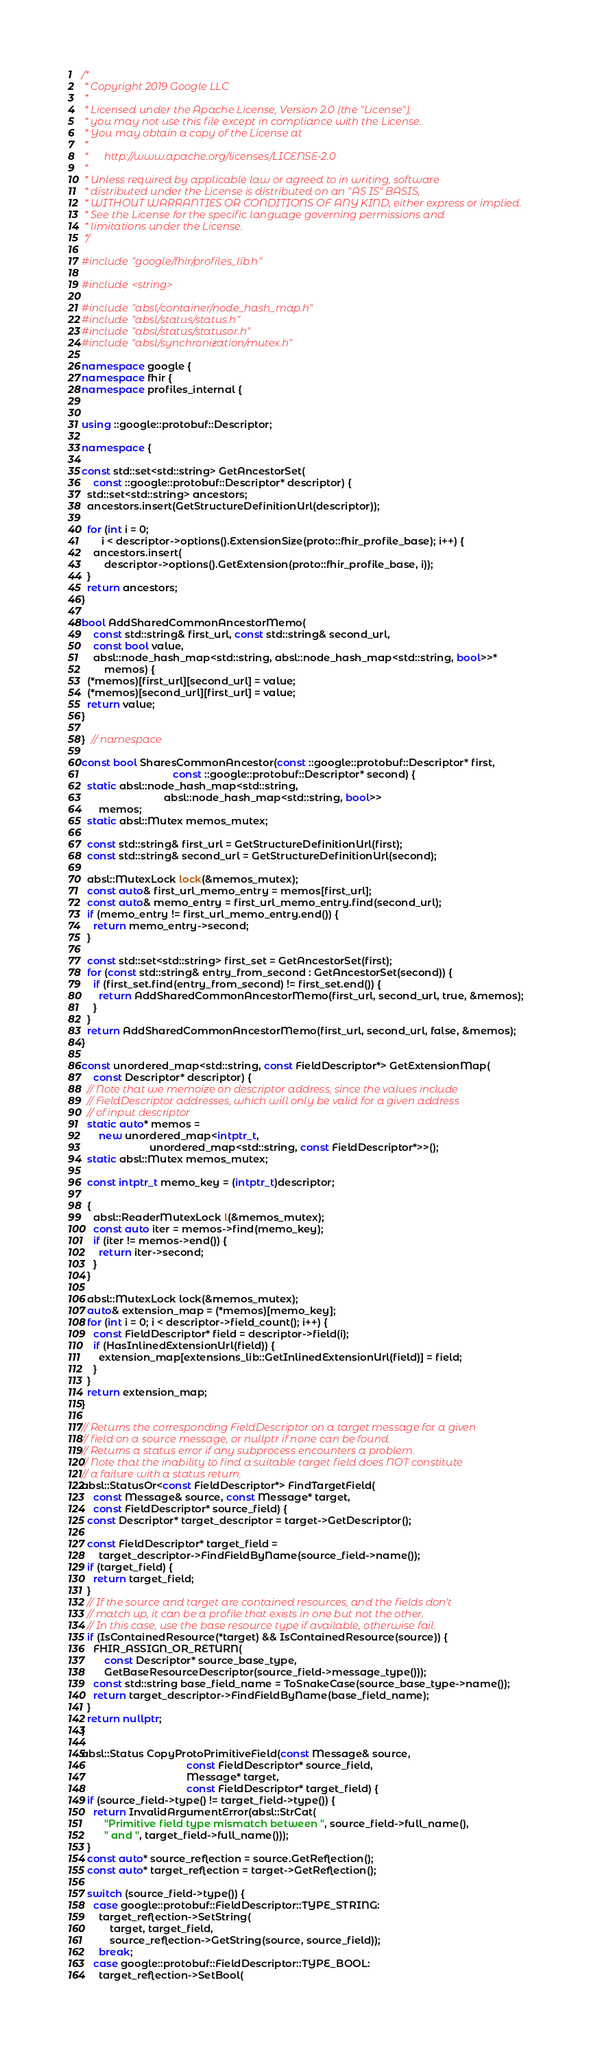Convert code to text. <code><loc_0><loc_0><loc_500><loc_500><_C++_>/*
 * Copyright 2019 Google LLC
 *
 * Licensed under the Apache License, Version 2.0 (the "License");
 * you may not use this file except in compliance with the License.
 * You may obtain a copy of the License at
 *
 *      http://www.apache.org/licenses/LICENSE-2.0
 *
 * Unless required by applicable law or agreed to in writing, software
 * distributed under the License is distributed on an "AS IS" BASIS,
 * WITHOUT WARRANTIES OR CONDITIONS OF ANY KIND, either express or implied.
 * See the License for the specific language governing permissions and
 * limitations under the License.
 */

#include "google/fhir/profiles_lib.h"

#include <string>

#include "absl/container/node_hash_map.h"
#include "absl/status/status.h"
#include "absl/status/statusor.h"
#include "absl/synchronization/mutex.h"

namespace google {
namespace fhir {
namespace profiles_internal {


using ::google::protobuf::Descriptor;

namespace {

const std::set<std::string> GetAncestorSet(
    const ::google::protobuf::Descriptor* descriptor) {
  std::set<std::string> ancestors;
  ancestors.insert(GetStructureDefinitionUrl(descriptor));

  for (int i = 0;
       i < descriptor->options().ExtensionSize(proto::fhir_profile_base); i++) {
    ancestors.insert(
        descriptor->options().GetExtension(proto::fhir_profile_base, i));
  }
  return ancestors;
}

bool AddSharedCommonAncestorMemo(
    const std::string& first_url, const std::string& second_url,
    const bool value,
    absl::node_hash_map<std::string, absl::node_hash_map<std::string, bool>>*
        memos) {
  (*memos)[first_url][second_url] = value;
  (*memos)[second_url][first_url] = value;
  return value;
}

}  // namespace

const bool SharesCommonAncestor(const ::google::protobuf::Descriptor* first,
                                const ::google::protobuf::Descriptor* second) {
  static absl::node_hash_map<std::string,
                             absl::node_hash_map<std::string, bool>>
      memos;
  static absl::Mutex memos_mutex;

  const std::string& first_url = GetStructureDefinitionUrl(first);
  const std::string& second_url = GetStructureDefinitionUrl(second);

  absl::MutexLock lock(&memos_mutex);
  const auto& first_url_memo_entry = memos[first_url];
  const auto& memo_entry = first_url_memo_entry.find(second_url);
  if (memo_entry != first_url_memo_entry.end()) {
    return memo_entry->second;
  }

  const std::set<std::string> first_set = GetAncestorSet(first);
  for (const std::string& entry_from_second : GetAncestorSet(second)) {
    if (first_set.find(entry_from_second) != first_set.end()) {
      return AddSharedCommonAncestorMemo(first_url, second_url, true, &memos);
    }
  }
  return AddSharedCommonAncestorMemo(first_url, second_url, false, &memos);
}

const unordered_map<std::string, const FieldDescriptor*> GetExtensionMap(
    const Descriptor* descriptor) {
  // Note that we memoize on descriptor address, since the values include
  // FieldDescriptor addresses, which will only be valid for a given address
  // of input descriptor
  static auto* memos =
      new unordered_map<intptr_t,
                        unordered_map<std::string, const FieldDescriptor*>>();
  static absl::Mutex memos_mutex;

  const intptr_t memo_key = (intptr_t)descriptor;

  {
    absl::ReaderMutexLock l(&memos_mutex);
    const auto iter = memos->find(memo_key);
    if (iter != memos->end()) {
      return iter->second;
    }
  }

  absl::MutexLock lock(&memos_mutex);
  auto& extension_map = (*memos)[memo_key];
  for (int i = 0; i < descriptor->field_count(); i++) {
    const FieldDescriptor* field = descriptor->field(i);
    if (HasInlinedExtensionUrl(field)) {
      extension_map[extensions_lib::GetInlinedExtensionUrl(field)] = field;
    }
  }
  return extension_map;
}

// Returns the corresponding FieldDescriptor on a target message for a given
// field on a source message, or nullptr if none can be found.
// Returns a status error if any subprocess encounters a problem.
// Note that the inability to find a suitable target field does NOT constitute
// a failure with a status return.
absl::StatusOr<const FieldDescriptor*> FindTargetField(
    const Message& source, const Message* target,
    const FieldDescriptor* source_field) {
  const Descriptor* target_descriptor = target->GetDescriptor();

  const FieldDescriptor* target_field =
      target_descriptor->FindFieldByName(source_field->name());
  if (target_field) {
    return target_field;
  }
  // If the source and target are contained resources, and the fields don't
  // match up, it can be a profile that exists in one but not the other.
  // In this case, use the base resource type if available, otherwise fail.
  if (IsContainedResource(*target) && IsContainedResource(source)) {
    FHIR_ASSIGN_OR_RETURN(
        const Descriptor* source_base_type,
        GetBaseResourceDescriptor(source_field->message_type()));
    const std::string base_field_name = ToSnakeCase(source_base_type->name());
    return target_descriptor->FindFieldByName(base_field_name);
  }
  return nullptr;
}

absl::Status CopyProtoPrimitiveField(const Message& source,
                                     const FieldDescriptor* source_field,
                                     Message* target,
                                     const FieldDescriptor* target_field) {
  if (source_field->type() != target_field->type()) {
    return InvalidArgumentError(absl::StrCat(
        "Primitive field type mismatch between ", source_field->full_name(),
        " and ", target_field->full_name()));
  }
  const auto* source_reflection = source.GetReflection();
  const auto* target_reflection = target->GetReflection();

  switch (source_field->type()) {
    case google::protobuf::FieldDescriptor::TYPE_STRING:
      target_reflection->SetString(
          target, target_field,
          source_reflection->GetString(source, source_field));
      break;
    case google::protobuf::FieldDescriptor::TYPE_BOOL:
      target_reflection->SetBool(</code> 